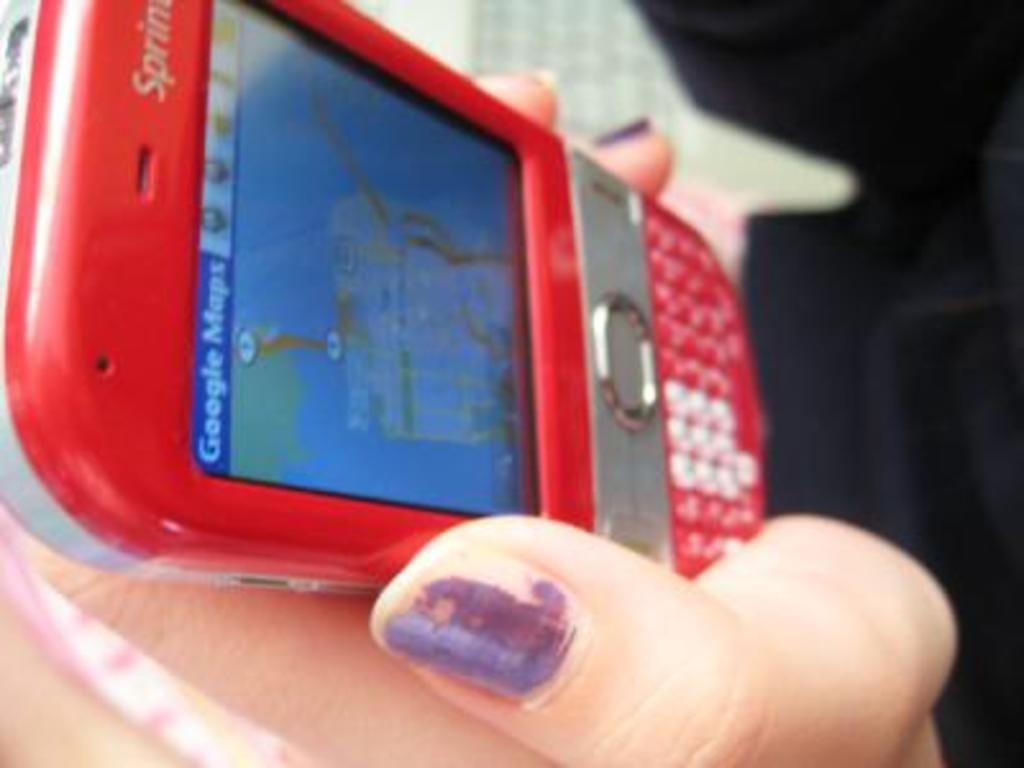<image>
Provide a brief description of the given image. A red Sprint cell phone with the screen showing google maps. 